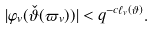Convert formula to latex. <formula><loc_0><loc_0><loc_500><loc_500>| \varphi _ { v } ( \check { \vartheta } ( \varpi _ { v } ) ) | < q ^ { - c { \ell _ { v } ( \vartheta ) } } .</formula> 